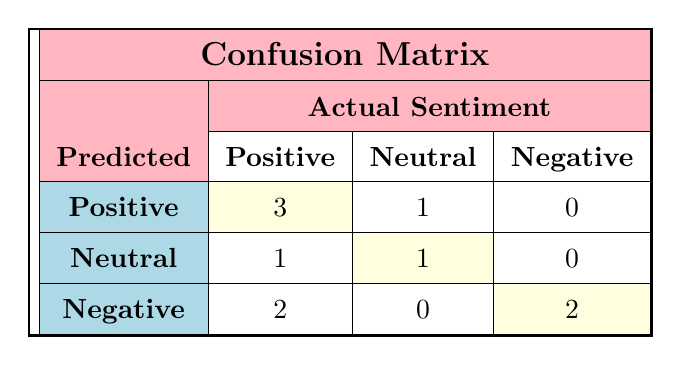What is the total number of positive sentiments predicted? To find the total number of positive sentiments predicted, we look at the first row (3 positives), the second row (1 positive), and the last row (0 positive) in the positive predicted column. Adding these gives us 3 + 1 + 0 = 4.
Answer: 4 How many influencers had a neutral sentiment predicted? From the confusion matrix, we observe the second column under predicted sentiment. There is 1 neutral prediction in the third row, and 0 in other rows, thus the total is 1.
Answer: 1 Is there any influencer for whom the predicted sentiment is neutral while the actual sentiment is negative? Looking at the matrix closely, there are no entries that show a neutral predicted sentiment paired with a negative actual sentiment. Therefore, the answer is no.
Answer: No What is the percentage of influencers correctly predicted with a positive sentiment? We have a total of 3 correct positive predictions and 2 incorrect (1 neutral and 2 negative) from the predicted positive row. The formula for percentage is (correct predictions / total predictions) × 100, which is (3 / 5) × 100 = 60%.
Answer: 60% How many total influencers were analyzed for sentiment? Total influencers can be found by counting all the influencers listed. Therefore, we see there are 10 influencers in total listed in the data set.
Answer: 10 What is the sum of negative actual sentiments predicted as positive? From the confusion matrix, we see that there are 0 cases where the actual sentiment was negative while predicted positive. Therefore, the sum is 0.
Answer: 0 How many influencers received a correct neutral sentiment prediction? Inspecting the matrix shows only 1 influencer (Desire Luzinda) received a correct neutral prediction. Hence, there is only 1 correct neutral sentiment prediction.
Answer: 1 What is the maximum number of negative sentiments predicted for any influencer? The last row indicates that 2 influencers were predicted as negative, from the negative predicted column. Hence, the maximum number predicted as negative is 2.
Answer: 2 